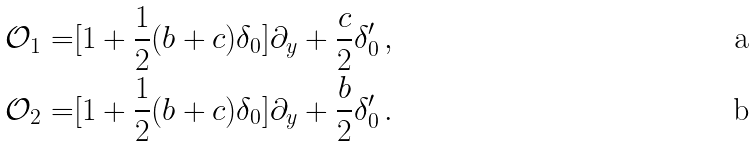Convert formula to latex. <formula><loc_0><loc_0><loc_500><loc_500>\mathcal { O } _ { 1 } = & [ 1 + \frac { 1 } { 2 } ( b + c ) \delta _ { 0 } ] \partial _ { y } + \frac { c } { 2 } \delta ^ { \prime } _ { 0 } \, , \\ \mathcal { O } _ { 2 } = & [ 1 + \frac { 1 } { 2 } ( b + c ) \delta _ { 0 } ] \partial _ { y } + \frac { b } { 2 } \delta ^ { \prime } _ { 0 } \, .</formula> 